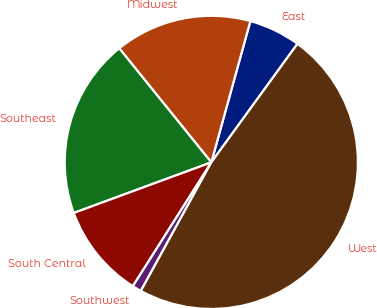Convert chart to OTSL. <chart><loc_0><loc_0><loc_500><loc_500><pie_chart><fcel>East<fcel>Midwest<fcel>Southeast<fcel>South Central<fcel>Southwest<fcel>West<nl><fcel>5.71%<fcel>15.1%<fcel>19.8%<fcel>10.4%<fcel>1.01%<fcel>47.98%<nl></chart> 